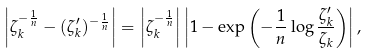Convert formula to latex. <formula><loc_0><loc_0><loc_500><loc_500>\left | \zeta _ { k } ^ { - \frac { 1 } { n } } - ( \zeta ^ { \prime } _ { k } ) ^ { - \frac { 1 } { n } } \right | = \left | \zeta _ { k } ^ { - \frac { 1 } { n } } \right | \left | 1 - \exp \left ( - \frac { 1 } { n } \log \frac { \zeta ^ { \prime } _ { k } } { \zeta _ { k } } \right ) \right | ,</formula> 